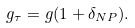<formula> <loc_0><loc_0><loc_500><loc_500>g _ { \tau } = g ( 1 + \delta _ { N P } ) .</formula> 